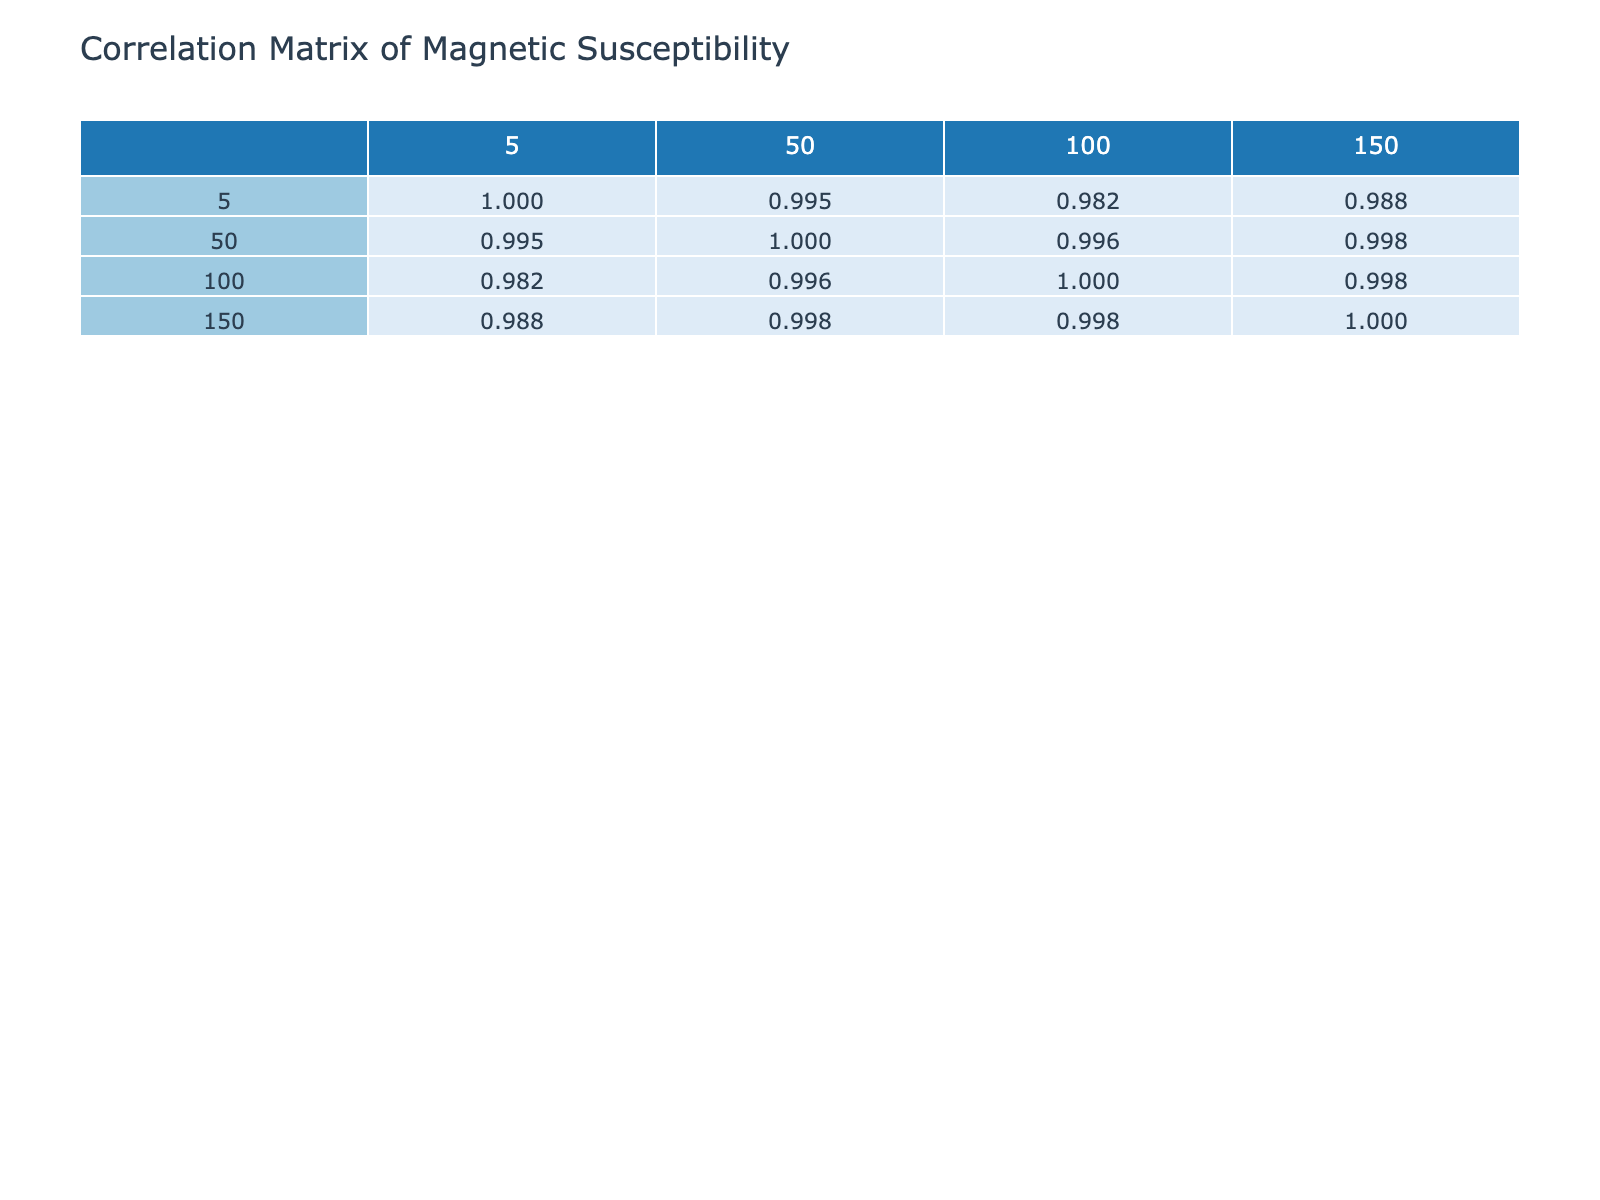What is the magnetic susceptibility of Iron at 100 K? The table shows that the magnetic susceptibility of Iron at 100 K is listed under the Iron row and 100 K column, which is 1.8e-3.
Answer: 1.8e-3 What is the change in magnetic susceptibility of Nickel from 5 K to 150 K? To find the change, we look at the values for Nickel at both temperatures: at 5 K, the value is 6.2e-3, and at 150 K, it is 4.2e-3. The change is 6.2e-3 - 4.2e-3 = 2.0e-3.
Answer: 2.0e-3 Is the magnetic susceptibility of Gadolinium higher at 5 K than at 50 K? Looking at the table, the susceptibility of Gadolinium at 5 K is 1.5e-2, and at 50 K it is 1.2e-2. Since 1.5e-2 is greater than 1.2e-2, the statement is true.
Answer: Yes Which material has the highest magnetic susceptibility at 5 K? The table presents the values of magnetic susceptibility for each material at 5 K. Copper shows 1.2e-5, Iron shows 2.5e-3, Nickel shows 6.2e-3, Cobalt shows 8.0e-3, and Gadolinium shows 1.5e-2. Here, 1.5e-2 for Gadolinium is the highest value.
Answer: Gadolinium What is the average magnetic susceptibility of Cobalt across all temperatures? To calculate the average, we sum the values of Cobalt at various temperatures: 8.0e-3 + 7.5e-3 + 7.1e-3 + 6.4e-3 = 29.0e-3. Then we divide by the number of temperatures (4), giving us an average of 29.0e-3 / 4 = 7.25e-3.
Answer: 7.25e-3 Does the magnetic susceptibility of Copper decrease consistently as temperature increases? The Copper values show: 1.2e-5 at 5 K, 2.0e-5 at 50 K, 1.8e-5 at 100 K, and 1.5e-5 at 150 K. It initially increases from 5 K to 50 K then decreases in subsequent measurements. Therefore, the susceptibility does not decrease consistently.
Answer: No What is the range of magnetic susceptibility for Iron across the given temperatures? The values for Iron are: 2.5e-3 (5 K) and 1.5e-3 (150 K). The range is calculated by taking the maximum value, 2.5e-3, and subtracting the minimum value, 1.5e-3, giving a range of 2.5e-3 - 1.5e-3 = 1.0e-3.
Answer: 1.0e-3 Which material shows the most significant decrease in magnetic susceptibility from 5 K to 150 K? We calculate the differences for each material: Iron (2.5e-3 to 1.5e-3 = 1.0e-3), Nickel (6.2e-3 to 4.2e-3 = 2.0e-3), Cobalt (8.0e-3 to 6.4e-3 = 1.6e-3), and Gadolinium (1.5e-2 to 9.5e-3 = 6.0e-3). Gadolinium shows the largest decrease of 6.0e-3.
Answer: Gadolinium 